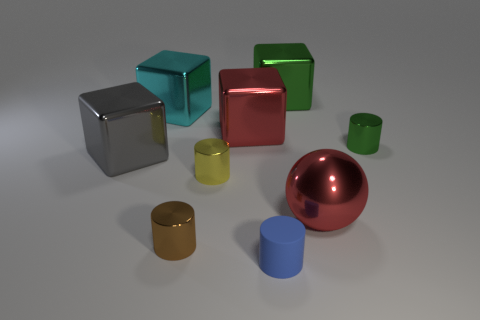Subtract all purple cylinders. Subtract all purple blocks. How many cylinders are left? 4 Add 1 tiny purple blocks. How many objects exist? 10 Subtract all spheres. How many objects are left? 8 Add 9 tiny yellow metallic cylinders. How many tiny yellow metallic cylinders are left? 10 Add 6 tiny purple metal things. How many tiny purple metal things exist? 6 Subtract 0 yellow balls. How many objects are left? 9 Subtract all tiny green shiny things. Subtract all yellow shiny cylinders. How many objects are left? 7 